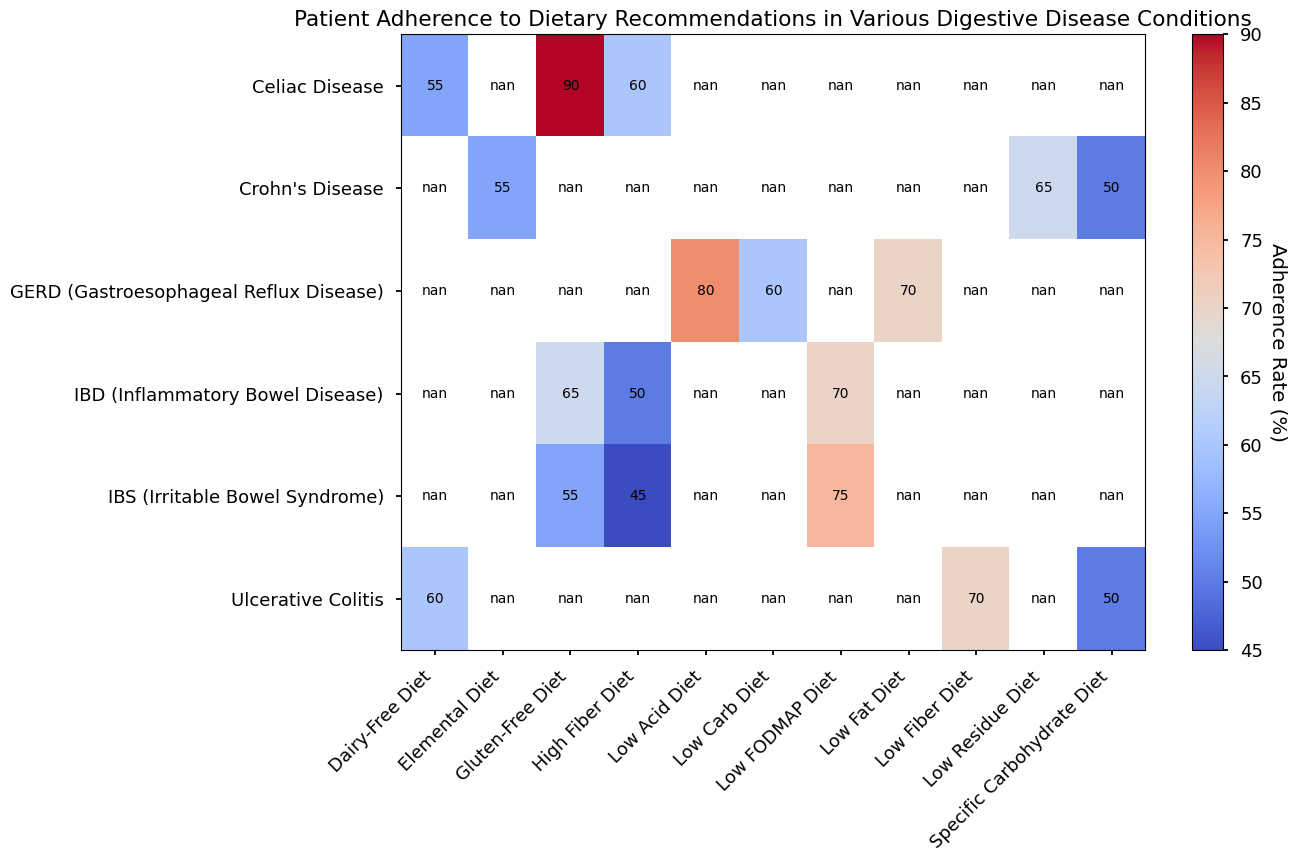Which condition has the highest adherence rate for the Low FODMAP Diet? To find the condition with the highest adherence rate for the Low FODMAP Diet, look at the 'Low FODMAP Diet' column and identify the highest value. The values are 70% for IBD and 75% for IBS. Thus, IBS has the highest adherence.
Answer: IBS What's the difference in adherence rates between the High Fiber Diet in IBD and the High Fiber Diet in IBS? Locate the adherence rates for the High Fiber Diet in both conditions: 50% for IBD and 45% for IBS. Subtract the lower rate from the higher rate: 50% - 45% = 5%.
Answer: 5% Which dietary recommendation has the highest overall adherence rate among all conditions? Identify and compare all adherence rates. The highest value is 90% for the Gluten-Free Diet in Celiac Disease.
Answer: Gluten-Free Diet in Celiac Disease Compare the adherence rates for Dairy-Free Diet between Ulcerative Colitis and Celiac Disease. Which one has a higher rate? Locate the adherence rates for Dairy-Free Diet: 60% for Ulcerative Colitis and 55% for Celiac Disease. The higher rate is for Ulcerative Colitis.
Answer: Ulcerative Colitis What's the average adherence rate for all recommendations in GERD? List the adherence rates for GERD: 80% (Low Acid Diet), 70% (Low Fat Diet), and 60% (Low Carb Diet). Calculate the average: (80 + 70 + 60) / 3 = 70%.
Answer: 70% Is the adherence rate for the Gluten-Free Diet higher in Celiac Disease or IBD? Compare the adherence rates for the Gluten-Free Diet: 65% in IBD and 90% in Celiac Disease. The higher rate is in Celiac Disease.
Answer: Celiac Disease Which condition has the lowest adherence rate for any dietary recommendation? Identify the lowest adherence rate in the table. The lowest value is 45% for the High Fiber Diet in IBS.
Answer: IBS What is the median adherence rate for the Low FODMAP Diet across all conditions? List adherence rates for Low FODMAP Diet: 70% (IBD) and 75% (IBS). Calculate the median: (70 + 75) / 2 = 72.5%.
Answer: 72.5% Which condition has a more varied adherence rate for its dietary recommendations, Crohn's Disease or Ulcerative Colitis? Observe the range of adherence rates for both conditions. Crohn's Disease ranges from 50% to 65% (variation of 15%), and Ulcerative Colitis ranges from 50% to 70% (variation of 20%). Thus, Ulcerative Colitis has a more varied adherence rate.
Answer: Ulcerative Colitis 